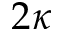<formula> <loc_0><loc_0><loc_500><loc_500>2 \kappa</formula> 